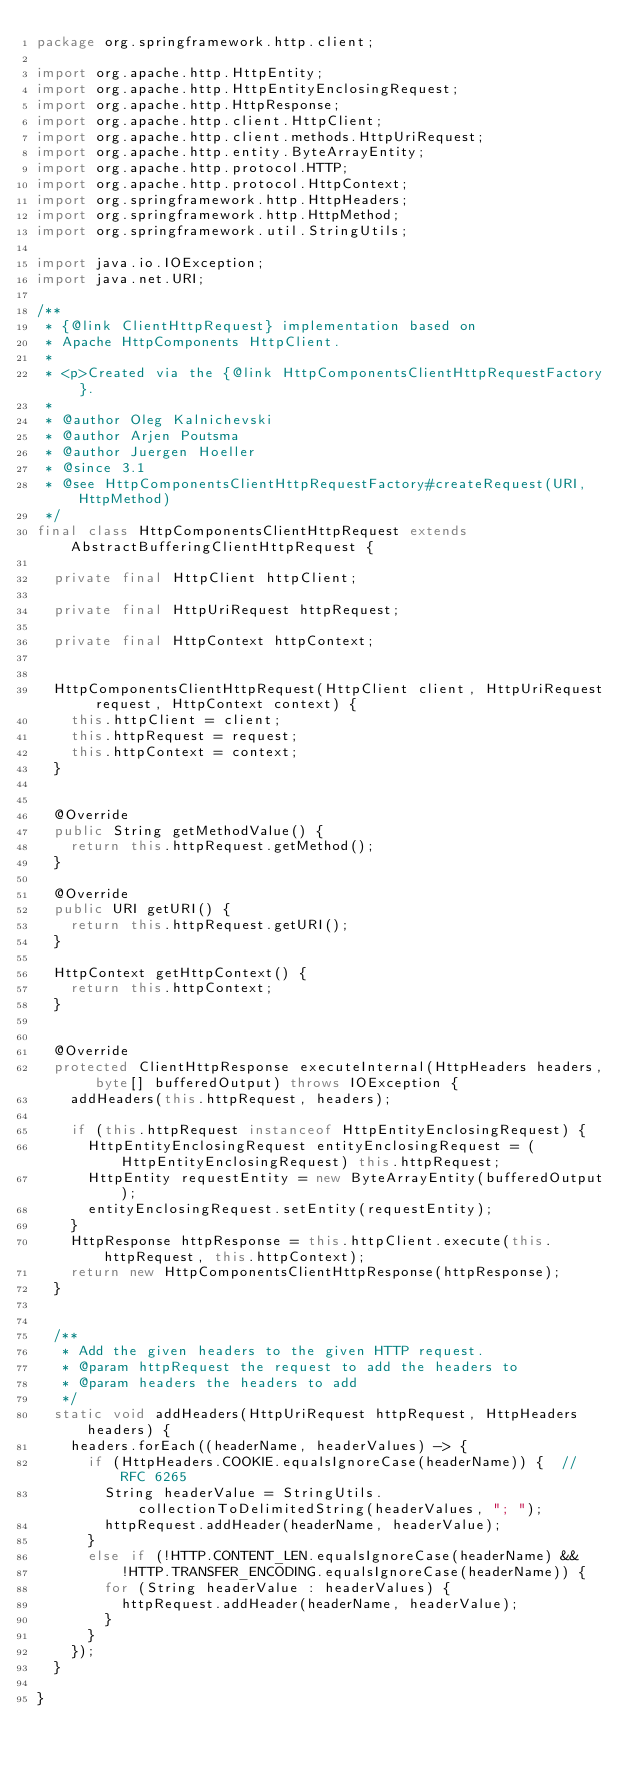Convert code to text. <code><loc_0><loc_0><loc_500><loc_500><_Java_>package org.springframework.http.client;

import org.apache.http.HttpEntity;
import org.apache.http.HttpEntityEnclosingRequest;
import org.apache.http.HttpResponse;
import org.apache.http.client.HttpClient;
import org.apache.http.client.methods.HttpUriRequest;
import org.apache.http.entity.ByteArrayEntity;
import org.apache.http.protocol.HTTP;
import org.apache.http.protocol.HttpContext;
import org.springframework.http.HttpHeaders;
import org.springframework.http.HttpMethod;
import org.springframework.util.StringUtils;

import java.io.IOException;
import java.net.URI;

/**
 * {@link ClientHttpRequest} implementation based on
 * Apache HttpComponents HttpClient.
 *
 * <p>Created via the {@link HttpComponentsClientHttpRequestFactory}.
 *
 * @author Oleg Kalnichevski
 * @author Arjen Poutsma
 * @author Juergen Hoeller
 * @since 3.1
 * @see HttpComponentsClientHttpRequestFactory#createRequest(URI, HttpMethod)
 */
final class HttpComponentsClientHttpRequest extends AbstractBufferingClientHttpRequest {

	private final HttpClient httpClient;

	private final HttpUriRequest httpRequest;

	private final HttpContext httpContext;


	HttpComponentsClientHttpRequest(HttpClient client, HttpUriRequest request, HttpContext context) {
		this.httpClient = client;
		this.httpRequest = request;
		this.httpContext = context;
	}


	@Override
	public String getMethodValue() {
		return this.httpRequest.getMethod();
	}

	@Override
	public URI getURI() {
		return this.httpRequest.getURI();
	}

	HttpContext getHttpContext() {
		return this.httpContext;
	}


	@Override
	protected ClientHttpResponse executeInternal(HttpHeaders headers, byte[] bufferedOutput) throws IOException {
		addHeaders(this.httpRequest, headers);

		if (this.httpRequest instanceof HttpEntityEnclosingRequest) {
			HttpEntityEnclosingRequest entityEnclosingRequest = (HttpEntityEnclosingRequest) this.httpRequest;
			HttpEntity requestEntity = new ByteArrayEntity(bufferedOutput);
			entityEnclosingRequest.setEntity(requestEntity);
		}
		HttpResponse httpResponse = this.httpClient.execute(this.httpRequest, this.httpContext);
		return new HttpComponentsClientHttpResponse(httpResponse);
	}


	/**
	 * Add the given headers to the given HTTP request.
	 * @param httpRequest the request to add the headers to
	 * @param headers the headers to add
	 */
	static void addHeaders(HttpUriRequest httpRequest, HttpHeaders headers) {
		headers.forEach((headerName, headerValues) -> {
			if (HttpHeaders.COOKIE.equalsIgnoreCase(headerName)) {  // RFC 6265
				String headerValue = StringUtils.collectionToDelimitedString(headerValues, "; ");
				httpRequest.addHeader(headerName, headerValue);
			}
			else if (!HTTP.CONTENT_LEN.equalsIgnoreCase(headerName) &&
					!HTTP.TRANSFER_ENCODING.equalsIgnoreCase(headerName)) {
				for (String headerValue : headerValues) {
					httpRequest.addHeader(headerName, headerValue);
				}
			}
		});
	}

}
</code> 